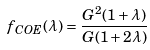<formula> <loc_0><loc_0><loc_500><loc_500>f _ { C O E } ( \lambda ) = \frac { G ^ { 2 } ( 1 + \lambda ) } { G ( 1 + 2 \lambda ) }</formula> 